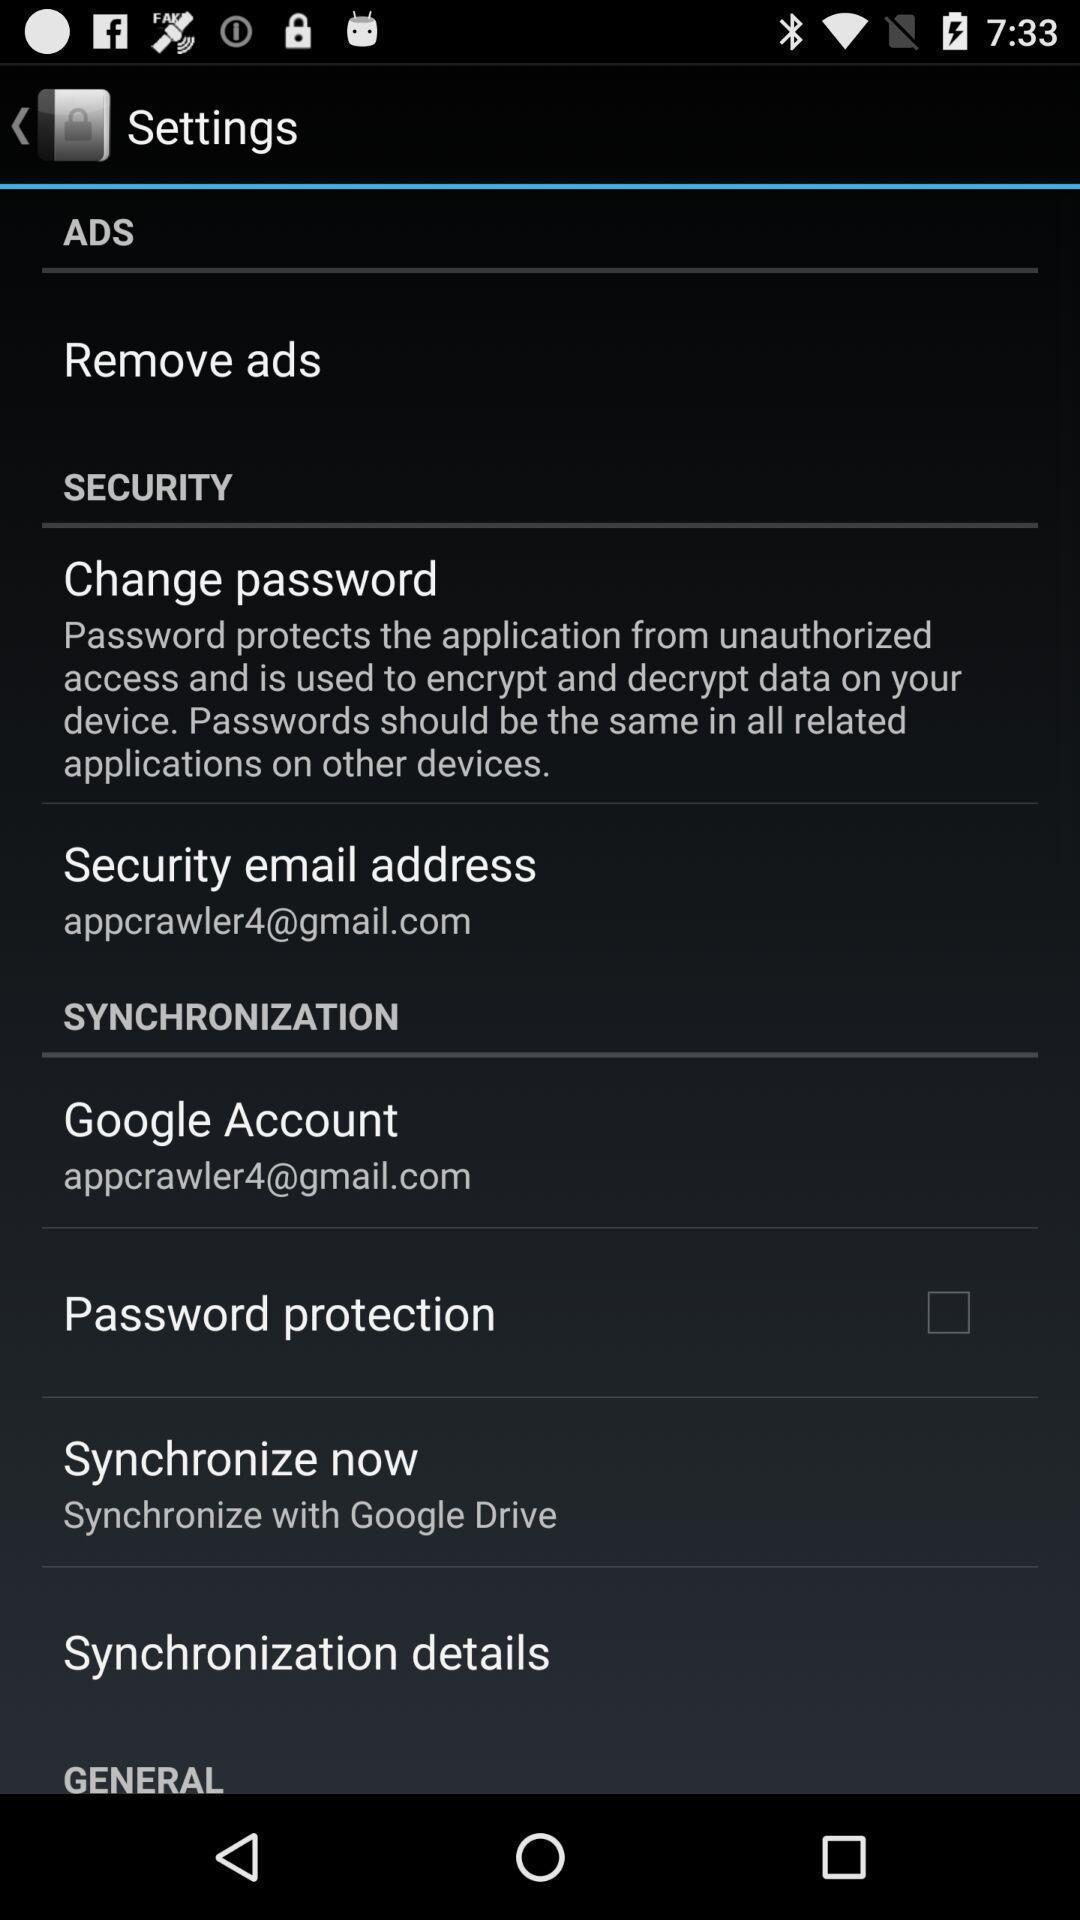Provide a detailed account of this screenshot. Settings page displaying various options. 